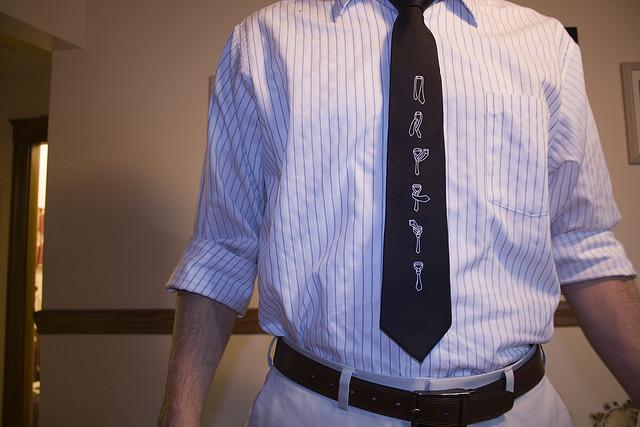The pictograms on the tie show how to do what?

Choices:
A) make it
B) iron it
C) tie it
D) wash it tie it 